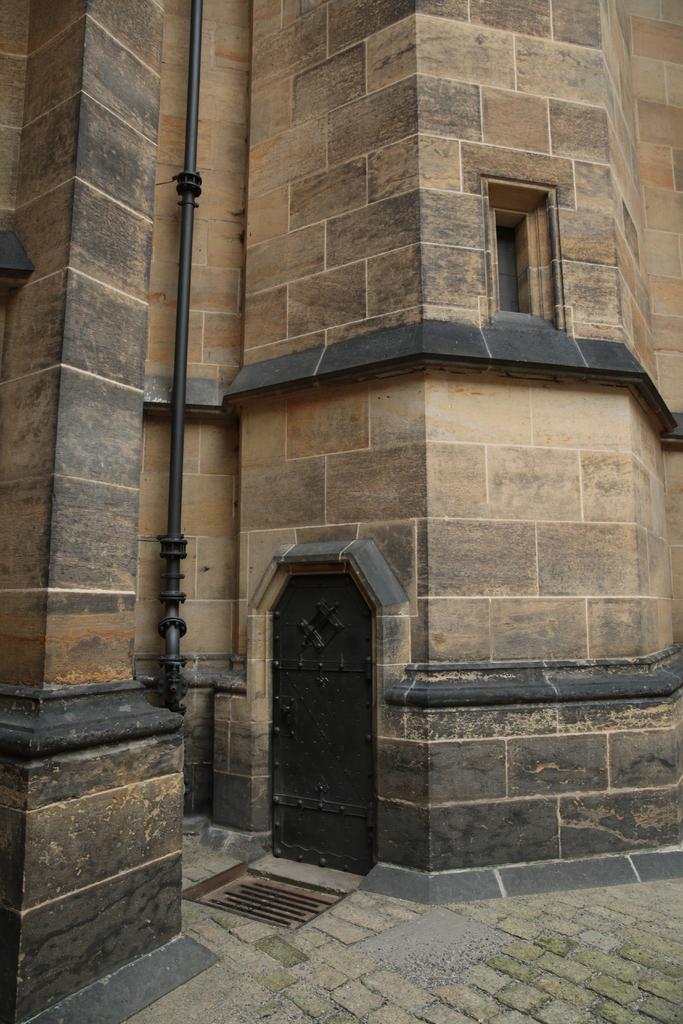Can you describe this image briefly? In this image there is a building. There are windows and a door to the wall of the building. There is a pipe on the building. At the bottom there is the ground. 